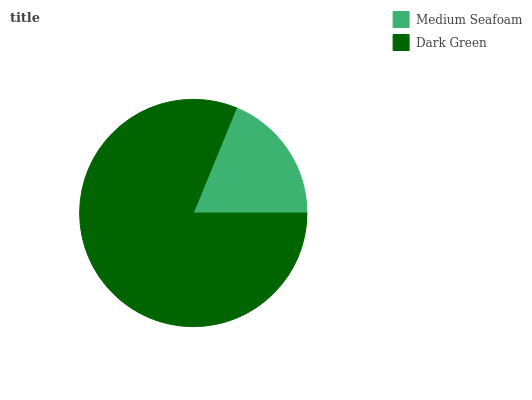Is Medium Seafoam the minimum?
Answer yes or no. Yes. Is Dark Green the maximum?
Answer yes or no. Yes. Is Dark Green the minimum?
Answer yes or no. No. Is Dark Green greater than Medium Seafoam?
Answer yes or no. Yes. Is Medium Seafoam less than Dark Green?
Answer yes or no. Yes. Is Medium Seafoam greater than Dark Green?
Answer yes or no. No. Is Dark Green less than Medium Seafoam?
Answer yes or no. No. Is Dark Green the high median?
Answer yes or no. Yes. Is Medium Seafoam the low median?
Answer yes or no. Yes. Is Medium Seafoam the high median?
Answer yes or no. No. Is Dark Green the low median?
Answer yes or no. No. 